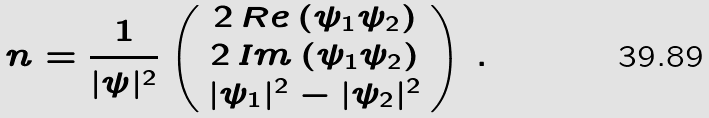Convert formula to latex. <formula><loc_0><loc_0><loc_500><loc_500>n = \frac { 1 } { | \psi | ^ { 2 } } \left ( \begin{array} { c } 2 \, R e \left ( \psi _ { 1 } \psi _ { 2 } \right ) \\ 2 \, I m \left ( \psi _ { 1 } \psi _ { 2 } \right ) \\ | \psi _ { 1 } | ^ { 2 } - | \psi _ { 2 } | ^ { 2 } \end{array} \right ) \, .</formula> 